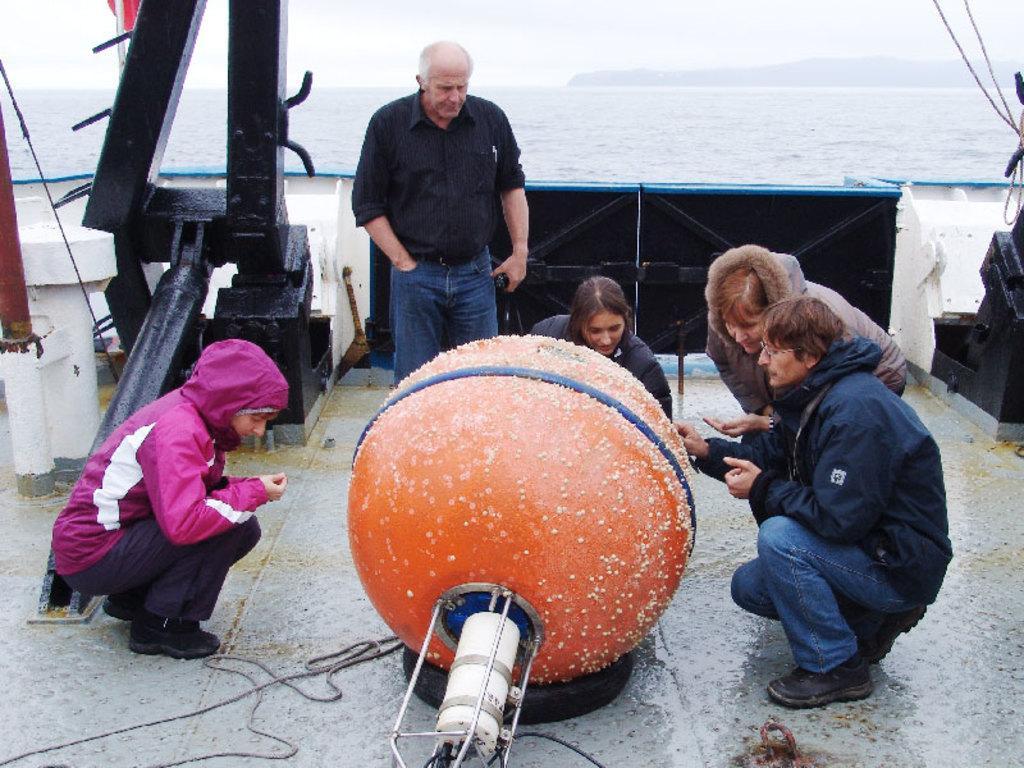In one or two sentences, can you explain what this image depicts? In this picture I can see a few people sitting on the surface. I can see a circular object. I can see water. I can see a person standing. I can see clouds in the sky. I can see mountains. 